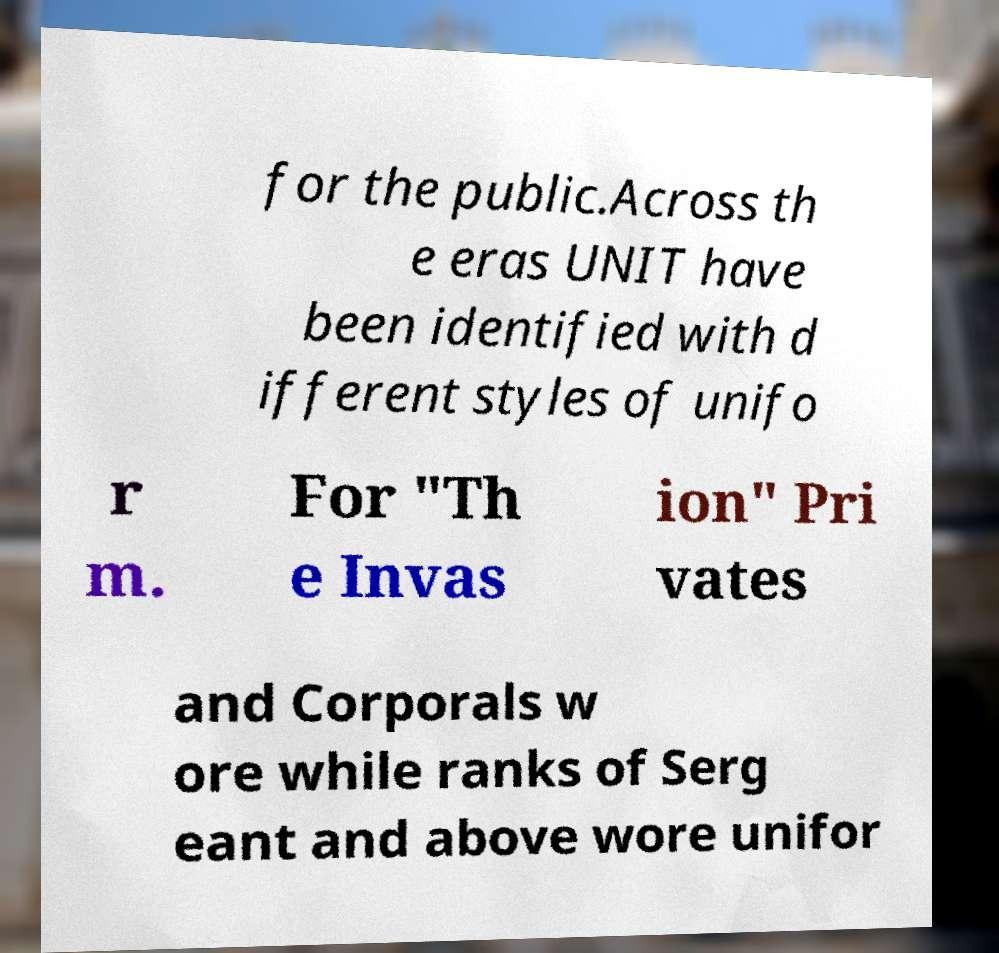Can you read and provide the text displayed in the image?This photo seems to have some interesting text. Can you extract and type it out for me? for the public.Across th e eras UNIT have been identified with d ifferent styles of unifo r m. For "Th e Invas ion" Pri vates and Corporals w ore while ranks of Serg eant and above wore unifor 